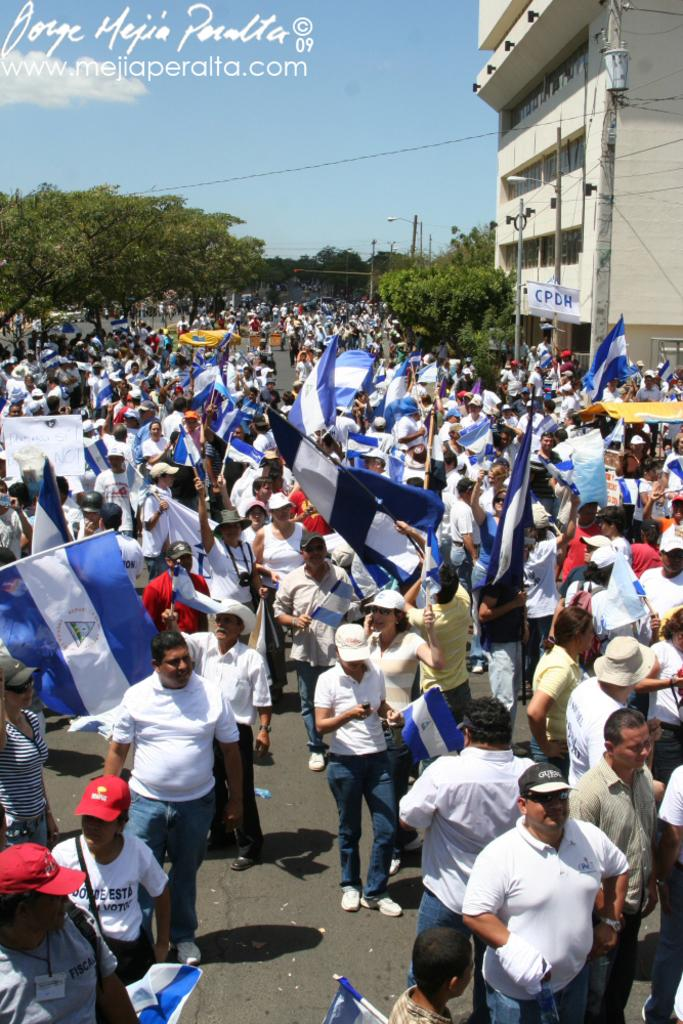What are the people in the image doing? The people in the image are standing on the road. What are the people holding in their hands? The people are holding flags in their hands. What type of natural elements can be seen in the image? There are trees visible in the image. What type of man-made structure is present in the image? There is a building in the image. What type of crayon is being used to draw on the building in the image? There is no crayon or drawing on the building in the image. How many chairs are visible in the image? There are no chairs visible in the image. 